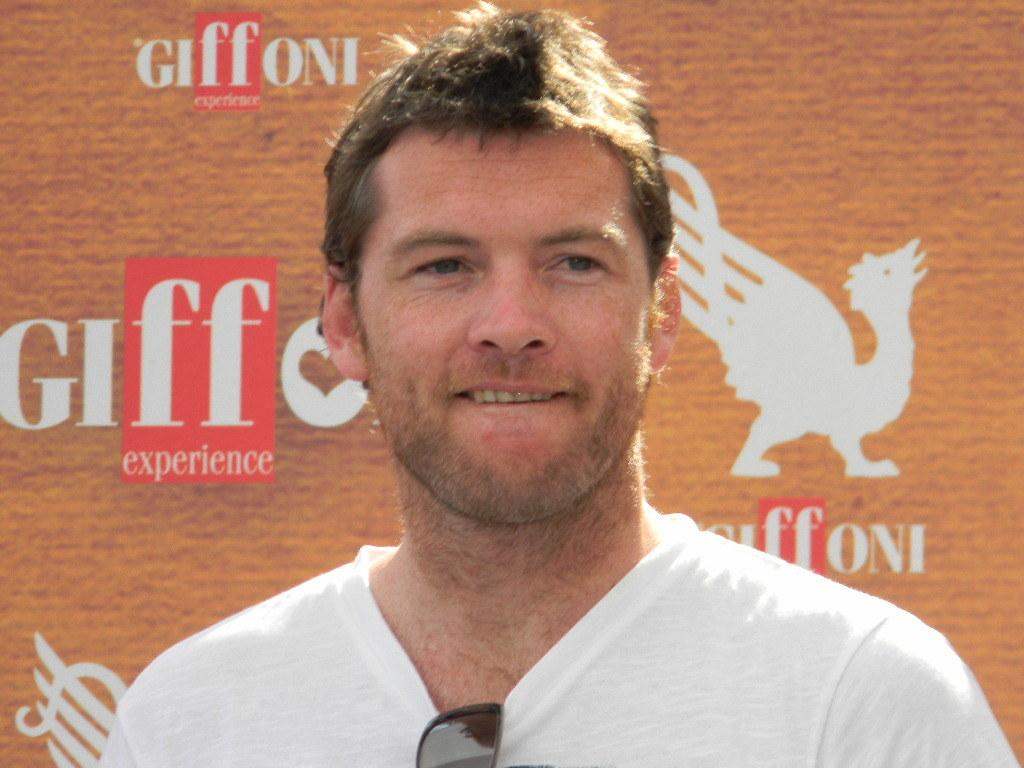Who is present in the image? There is a man in the image. What can be seen in the background of the image? There is an advertisement board with text in the background of the image. What type of chalk is being used to draw on the advertisement board in the image? There is no chalk present in the image, and no drawing activity is taking place on the advertisement board. 